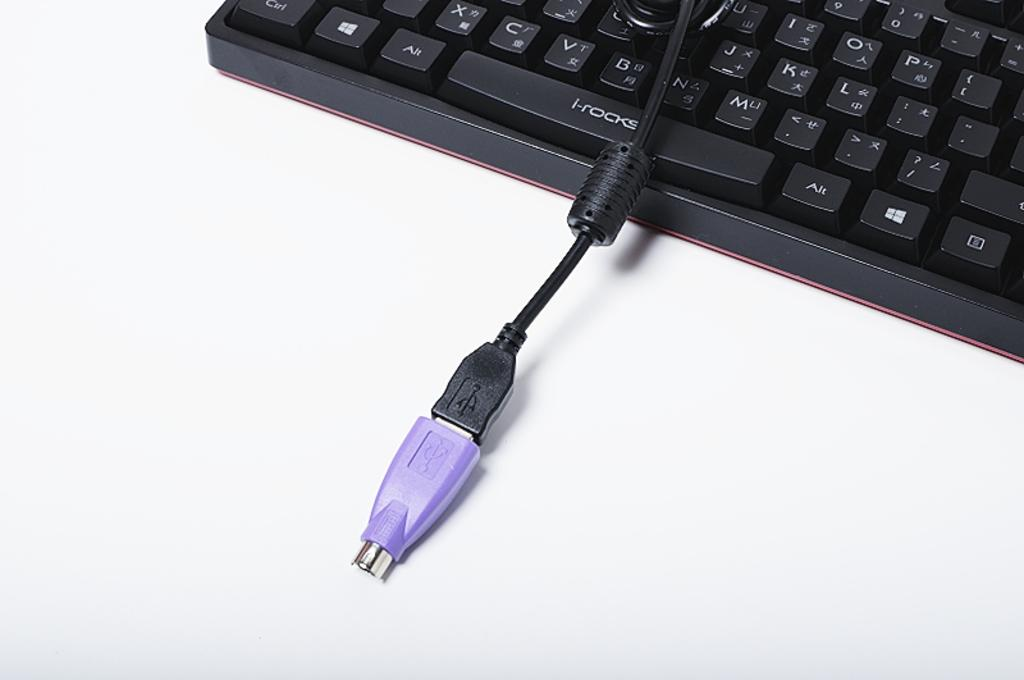Provide a one-sentence caption for the provided image. A keyboard with I-Rocks on the space bar. 